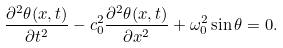Convert formula to latex. <formula><loc_0><loc_0><loc_500><loc_500>\frac { \partial ^ { 2 } \theta ( x , t ) } { \partial t ^ { 2 } } - c _ { 0 } ^ { 2 } \frac { \partial ^ { 2 } \theta ( x , t ) } { \partial x ^ { 2 } } + \omega _ { 0 } ^ { 2 } \sin \theta = 0 .</formula> 